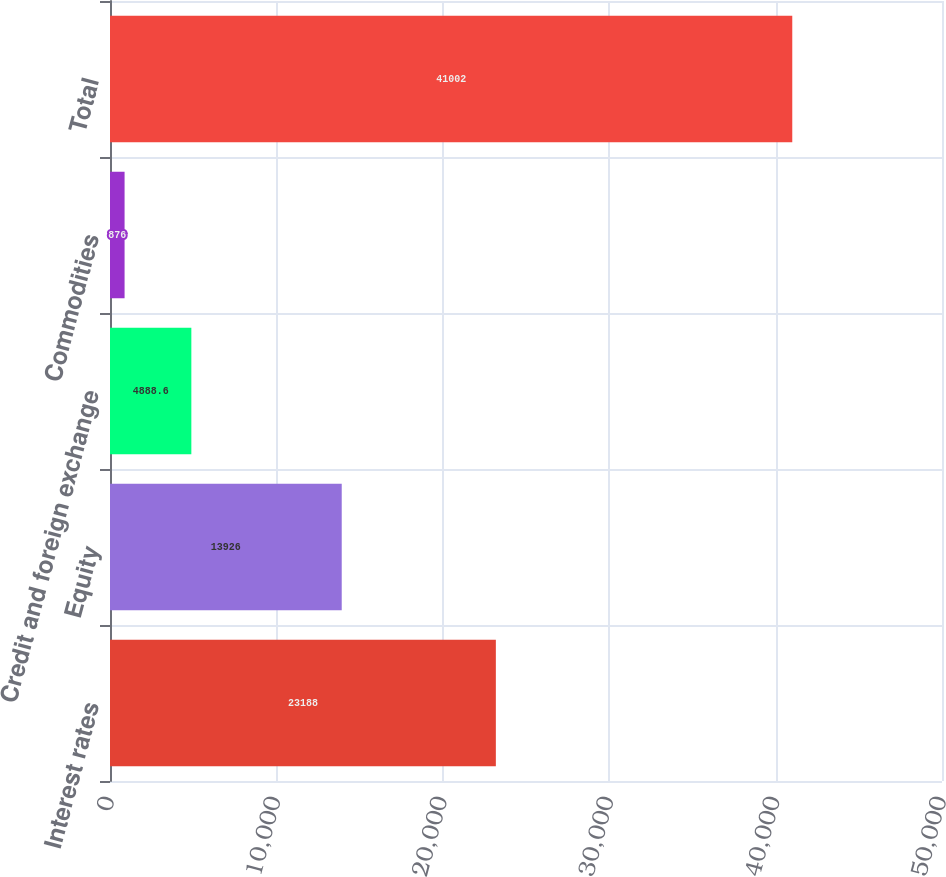Convert chart to OTSL. <chart><loc_0><loc_0><loc_500><loc_500><bar_chart><fcel>Interest rates<fcel>Equity<fcel>Credit and foreign exchange<fcel>Commodities<fcel>Total<nl><fcel>23188<fcel>13926<fcel>4888.6<fcel>876<fcel>41002<nl></chart> 